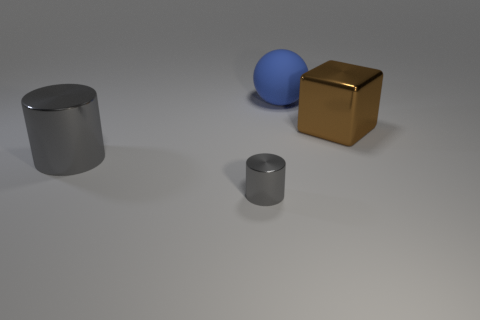How many gray cylinders must be subtracted to get 1 gray cylinders? 1 Add 3 brown rubber objects. How many objects exist? 7 Subtract all big cylinders. Subtract all metal spheres. How many objects are left? 3 Add 2 big gray cylinders. How many big gray cylinders are left? 3 Add 2 cyan metal cylinders. How many cyan metal cylinders exist? 2 Subtract 0 cyan blocks. How many objects are left? 4 Subtract all cubes. How many objects are left? 3 Subtract 2 cylinders. How many cylinders are left? 0 Subtract all yellow cubes. Subtract all red cylinders. How many cubes are left? 1 